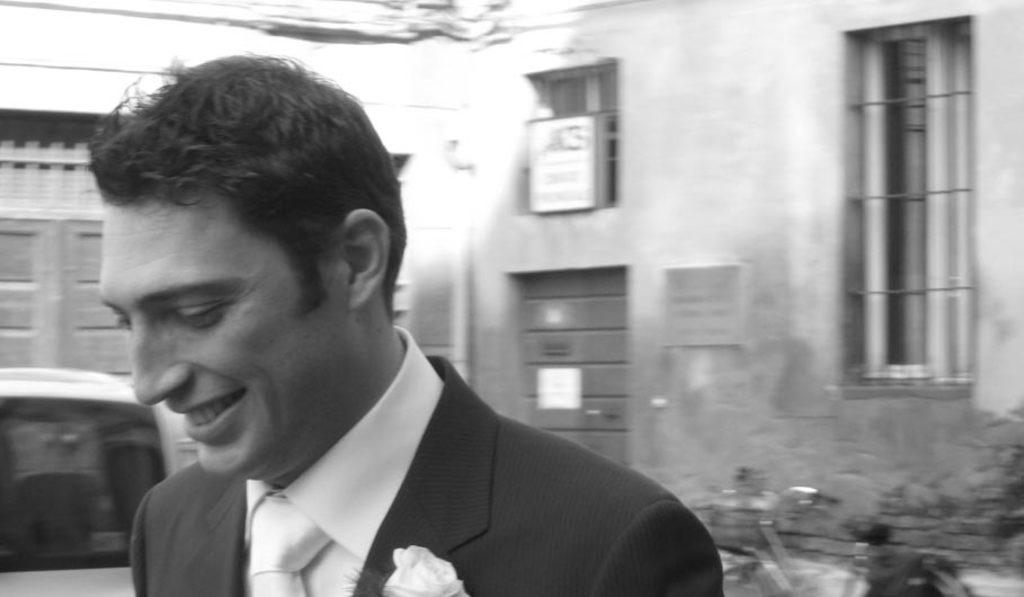Who is present in the image? There is a man in the image. What is the man doing in the image? The man is laughing in the image. What can be seen behind the man? There is a building behind the man. What is located in front of the building? There is a vehicle in front of the building. What type of thrill can be seen in the image? There is no specific thrill depicted in the image; it shows a man laughing in front of a building with a vehicle in front of it. 